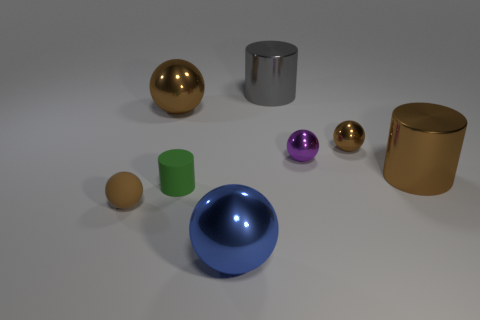Are there more tiny green things in front of the large blue sphere than brown cylinders?
Your answer should be compact. No. What is the shape of the small purple thing that is made of the same material as the large gray cylinder?
Make the answer very short. Sphere. The thing behind the big brown object that is to the left of the purple ball is what color?
Your response must be concise. Gray. Do the small brown matte object and the small brown metallic object have the same shape?
Your answer should be very brief. Yes. There is a big brown object that is the same shape as the small purple metal object; what is its material?
Offer a very short reply. Metal. There is a metal cylinder in front of the tiny brown sphere that is right of the small rubber sphere; are there any small balls in front of it?
Provide a short and direct response. Yes. Do the green matte thing and the object in front of the rubber sphere have the same shape?
Ensure brevity in your answer.  No. Are there any other things that have the same color as the tiny rubber sphere?
Your answer should be compact. Yes. Does the big metal thing that is to the left of the tiny matte cylinder have the same color as the big cylinder that is in front of the gray shiny cylinder?
Keep it short and to the point. Yes. Is there a large sphere?
Make the answer very short. Yes. 